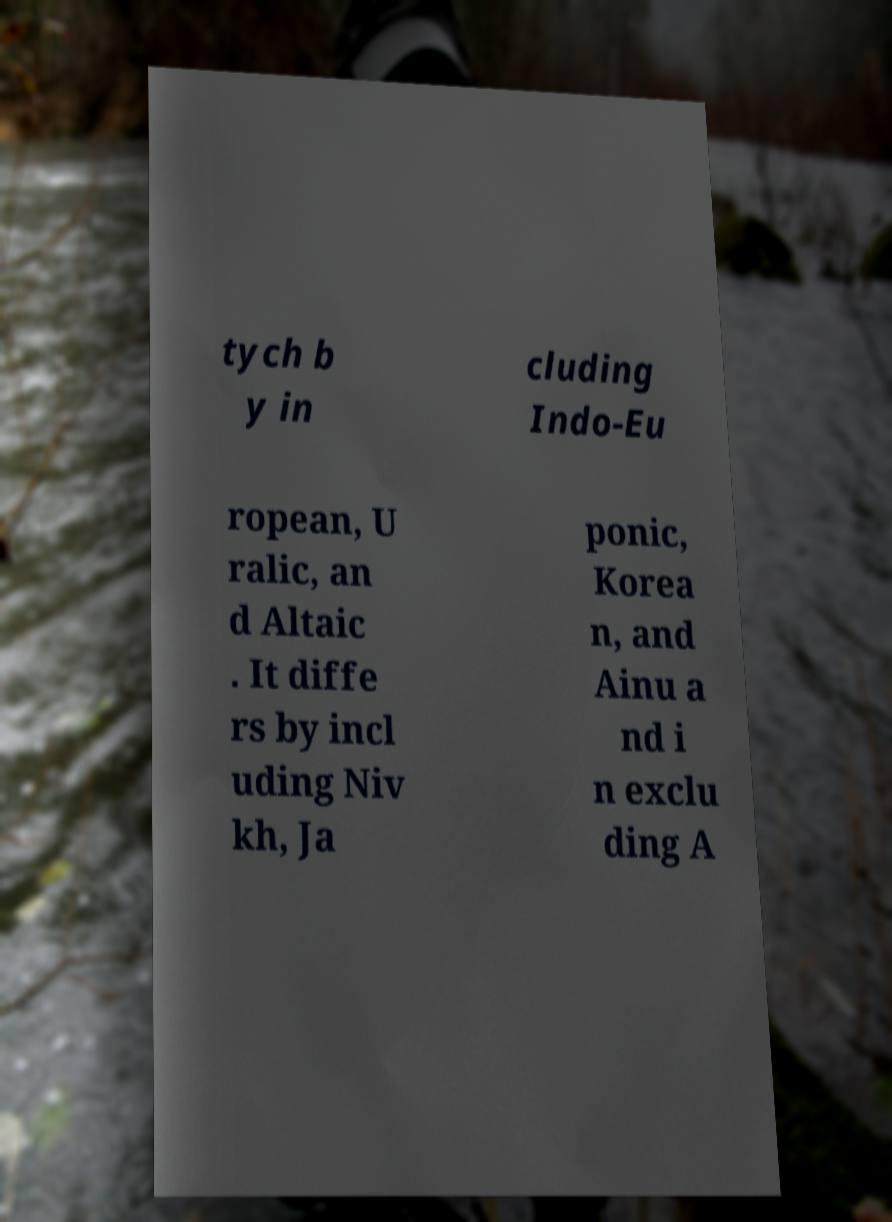Can you accurately transcribe the text from the provided image for me? tych b y in cluding Indo-Eu ropean, U ralic, an d Altaic . It diffe rs by incl uding Niv kh, Ja ponic, Korea n, and Ainu a nd i n exclu ding A 